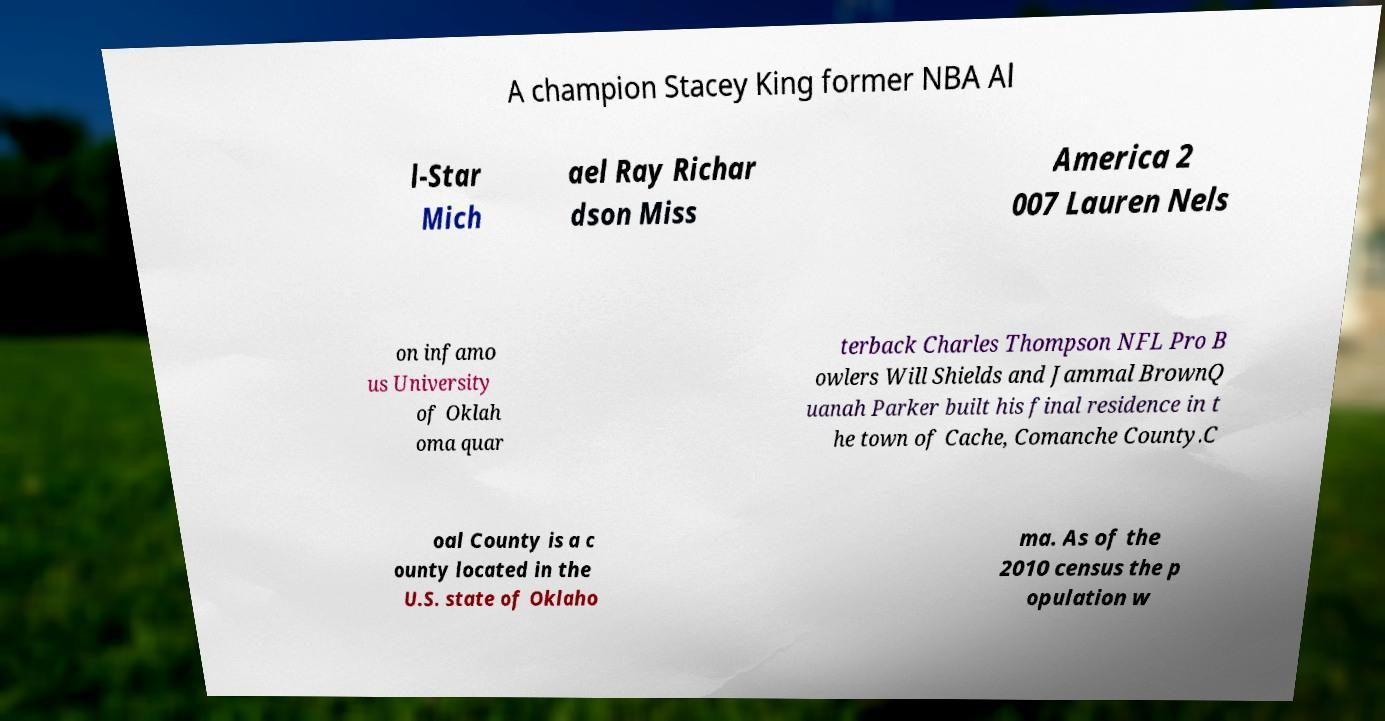Could you assist in decoding the text presented in this image and type it out clearly? A champion Stacey King former NBA Al l-Star Mich ael Ray Richar dson Miss America 2 007 Lauren Nels on infamo us University of Oklah oma quar terback Charles Thompson NFL Pro B owlers Will Shields and Jammal BrownQ uanah Parker built his final residence in t he town of Cache, Comanche County.C oal County is a c ounty located in the U.S. state of Oklaho ma. As of the 2010 census the p opulation w 